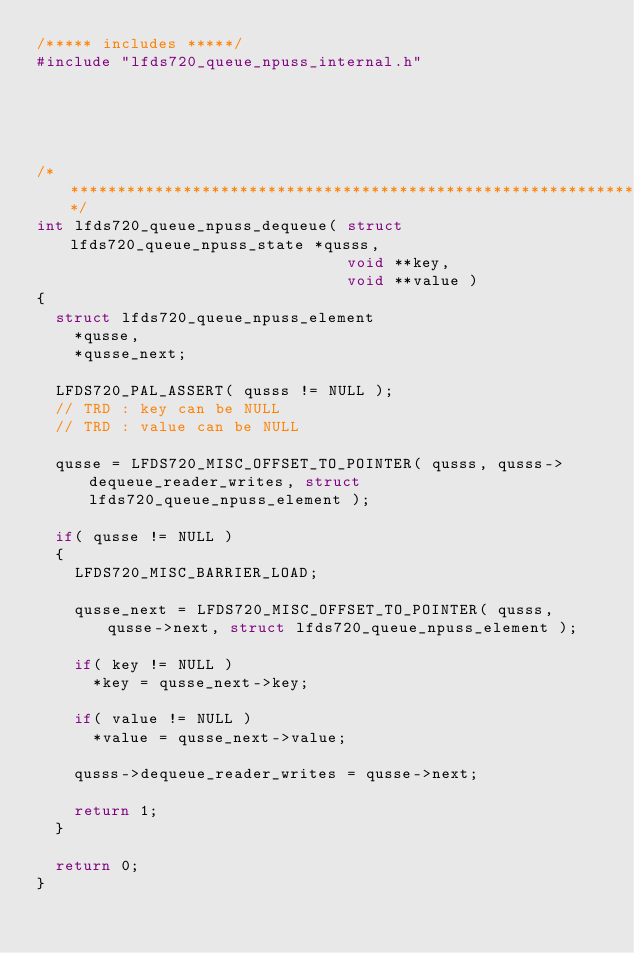<code> <loc_0><loc_0><loc_500><loc_500><_C_>/***** includes *****/
#include "lfds720_queue_npuss_internal.h"





/****************************************************************************/
int lfds720_queue_npuss_dequeue( struct lfds720_queue_npuss_state *qusss,
                                 void **key,
                                 void **value )
{
  struct lfds720_queue_npuss_element
    *qusse,
    *qusse_next;

  LFDS720_PAL_ASSERT( qusss != NULL );
  // TRD : key can be NULL
  // TRD : value can be NULL

  qusse = LFDS720_MISC_OFFSET_TO_POINTER( qusss, qusss->dequeue_reader_writes, struct lfds720_queue_npuss_element );

  if( qusse != NULL )
  {
    LFDS720_MISC_BARRIER_LOAD;

    qusse_next = LFDS720_MISC_OFFSET_TO_POINTER( qusss, qusse->next, struct lfds720_queue_npuss_element );

    if( key != NULL )
      *key = qusse_next->key;

    if( value != NULL )
      *value = qusse_next->value;

    qusss->dequeue_reader_writes = qusse->next;

    return 1;
  }

  return 0;
}

</code> 